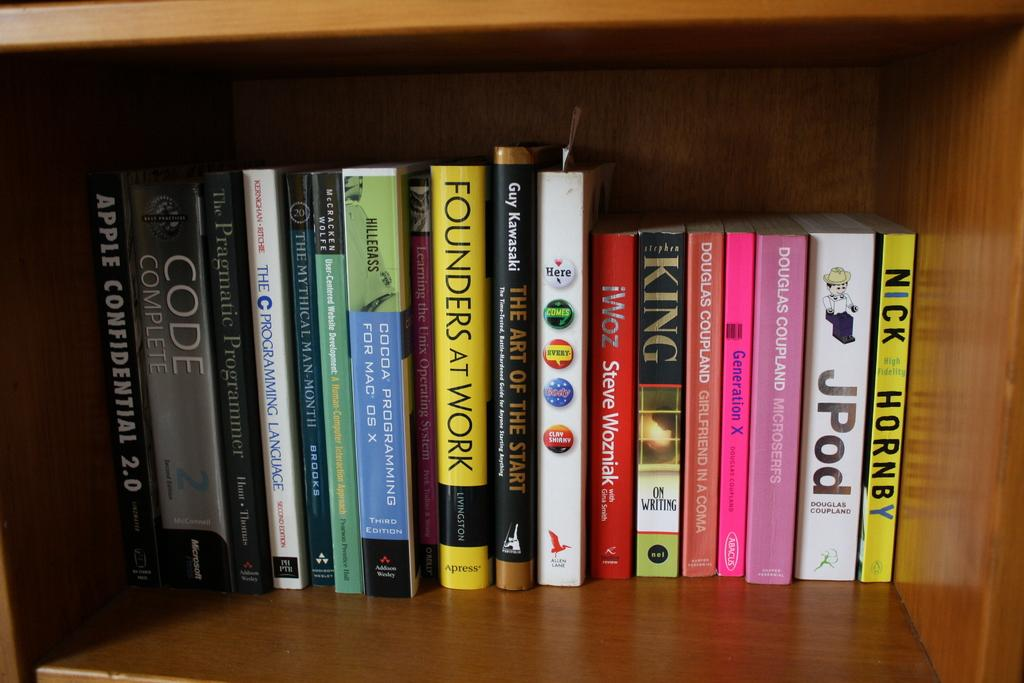Provide a one-sentence caption for the provided image. Many books are on a shelf, including Nick Hornby's High Fidelity. 